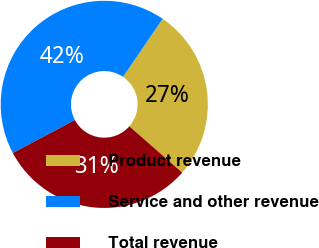<chart> <loc_0><loc_0><loc_500><loc_500><pie_chart><fcel>Product revenue<fcel>Service and other revenue<fcel>Total revenue<nl><fcel>26.92%<fcel>42.31%<fcel>30.77%<nl></chart> 